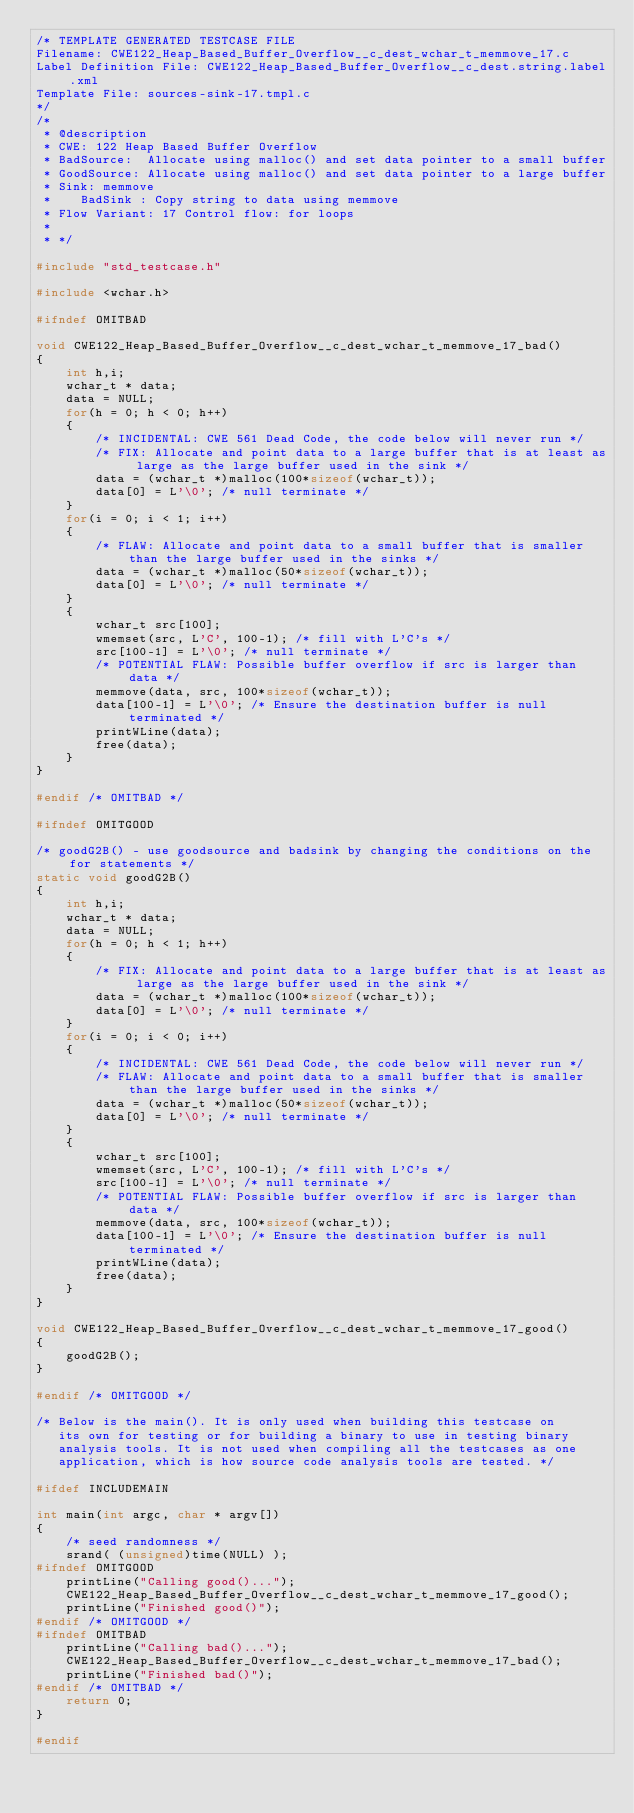<code> <loc_0><loc_0><loc_500><loc_500><_C_>/* TEMPLATE GENERATED TESTCASE FILE
Filename: CWE122_Heap_Based_Buffer_Overflow__c_dest_wchar_t_memmove_17.c
Label Definition File: CWE122_Heap_Based_Buffer_Overflow__c_dest.string.label.xml
Template File: sources-sink-17.tmpl.c
*/
/*
 * @description
 * CWE: 122 Heap Based Buffer Overflow
 * BadSource:  Allocate using malloc() and set data pointer to a small buffer
 * GoodSource: Allocate using malloc() and set data pointer to a large buffer
 * Sink: memmove
 *    BadSink : Copy string to data using memmove
 * Flow Variant: 17 Control flow: for loops
 *
 * */

#include "std_testcase.h"

#include <wchar.h>

#ifndef OMITBAD

void CWE122_Heap_Based_Buffer_Overflow__c_dest_wchar_t_memmove_17_bad()
{
    int h,i;
    wchar_t * data;
    data = NULL;
    for(h = 0; h < 0; h++)
    {
        /* INCIDENTAL: CWE 561 Dead Code, the code below will never run */
        /* FIX: Allocate and point data to a large buffer that is at least as large as the large buffer used in the sink */
        data = (wchar_t *)malloc(100*sizeof(wchar_t));
        data[0] = L'\0'; /* null terminate */
    }
    for(i = 0; i < 1; i++)
    {
        /* FLAW: Allocate and point data to a small buffer that is smaller than the large buffer used in the sinks */
        data = (wchar_t *)malloc(50*sizeof(wchar_t));
        data[0] = L'\0'; /* null terminate */
    }
    {
        wchar_t src[100];
        wmemset(src, L'C', 100-1); /* fill with L'C's */
        src[100-1] = L'\0'; /* null terminate */
        /* POTENTIAL FLAW: Possible buffer overflow if src is larger than data */
        memmove(data, src, 100*sizeof(wchar_t));
        data[100-1] = L'\0'; /* Ensure the destination buffer is null terminated */
        printWLine(data);
        free(data);
    }
}

#endif /* OMITBAD */

#ifndef OMITGOOD

/* goodG2B() - use goodsource and badsink by changing the conditions on the for statements */
static void goodG2B()
{
    int h,i;
    wchar_t * data;
    data = NULL;
    for(h = 0; h < 1; h++)
    {
        /* FIX: Allocate and point data to a large buffer that is at least as large as the large buffer used in the sink */
        data = (wchar_t *)malloc(100*sizeof(wchar_t));
        data[0] = L'\0'; /* null terminate */
    }
    for(i = 0; i < 0; i++)
    {
        /* INCIDENTAL: CWE 561 Dead Code, the code below will never run */
        /* FLAW: Allocate and point data to a small buffer that is smaller than the large buffer used in the sinks */
        data = (wchar_t *)malloc(50*sizeof(wchar_t));
        data[0] = L'\0'; /* null terminate */
    }
    {
        wchar_t src[100];
        wmemset(src, L'C', 100-1); /* fill with L'C's */
        src[100-1] = L'\0'; /* null terminate */
        /* POTENTIAL FLAW: Possible buffer overflow if src is larger than data */
        memmove(data, src, 100*sizeof(wchar_t));
        data[100-1] = L'\0'; /* Ensure the destination buffer is null terminated */
        printWLine(data);
        free(data);
    }
}

void CWE122_Heap_Based_Buffer_Overflow__c_dest_wchar_t_memmove_17_good()
{
    goodG2B();
}

#endif /* OMITGOOD */

/* Below is the main(). It is only used when building this testcase on
   its own for testing or for building a binary to use in testing binary
   analysis tools. It is not used when compiling all the testcases as one
   application, which is how source code analysis tools are tested. */

#ifdef INCLUDEMAIN

int main(int argc, char * argv[])
{
    /* seed randomness */
    srand( (unsigned)time(NULL) );
#ifndef OMITGOOD
    printLine("Calling good()...");
    CWE122_Heap_Based_Buffer_Overflow__c_dest_wchar_t_memmove_17_good();
    printLine("Finished good()");
#endif /* OMITGOOD */
#ifndef OMITBAD
    printLine("Calling bad()...");
    CWE122_Heap_Based_Buffer_Overflow__c_dest_wchar_t_memmove_17_bad();
    printLine("Finished bad()");
#endif /* OMITBAD */
    return 0;
}

#endif
</code> 